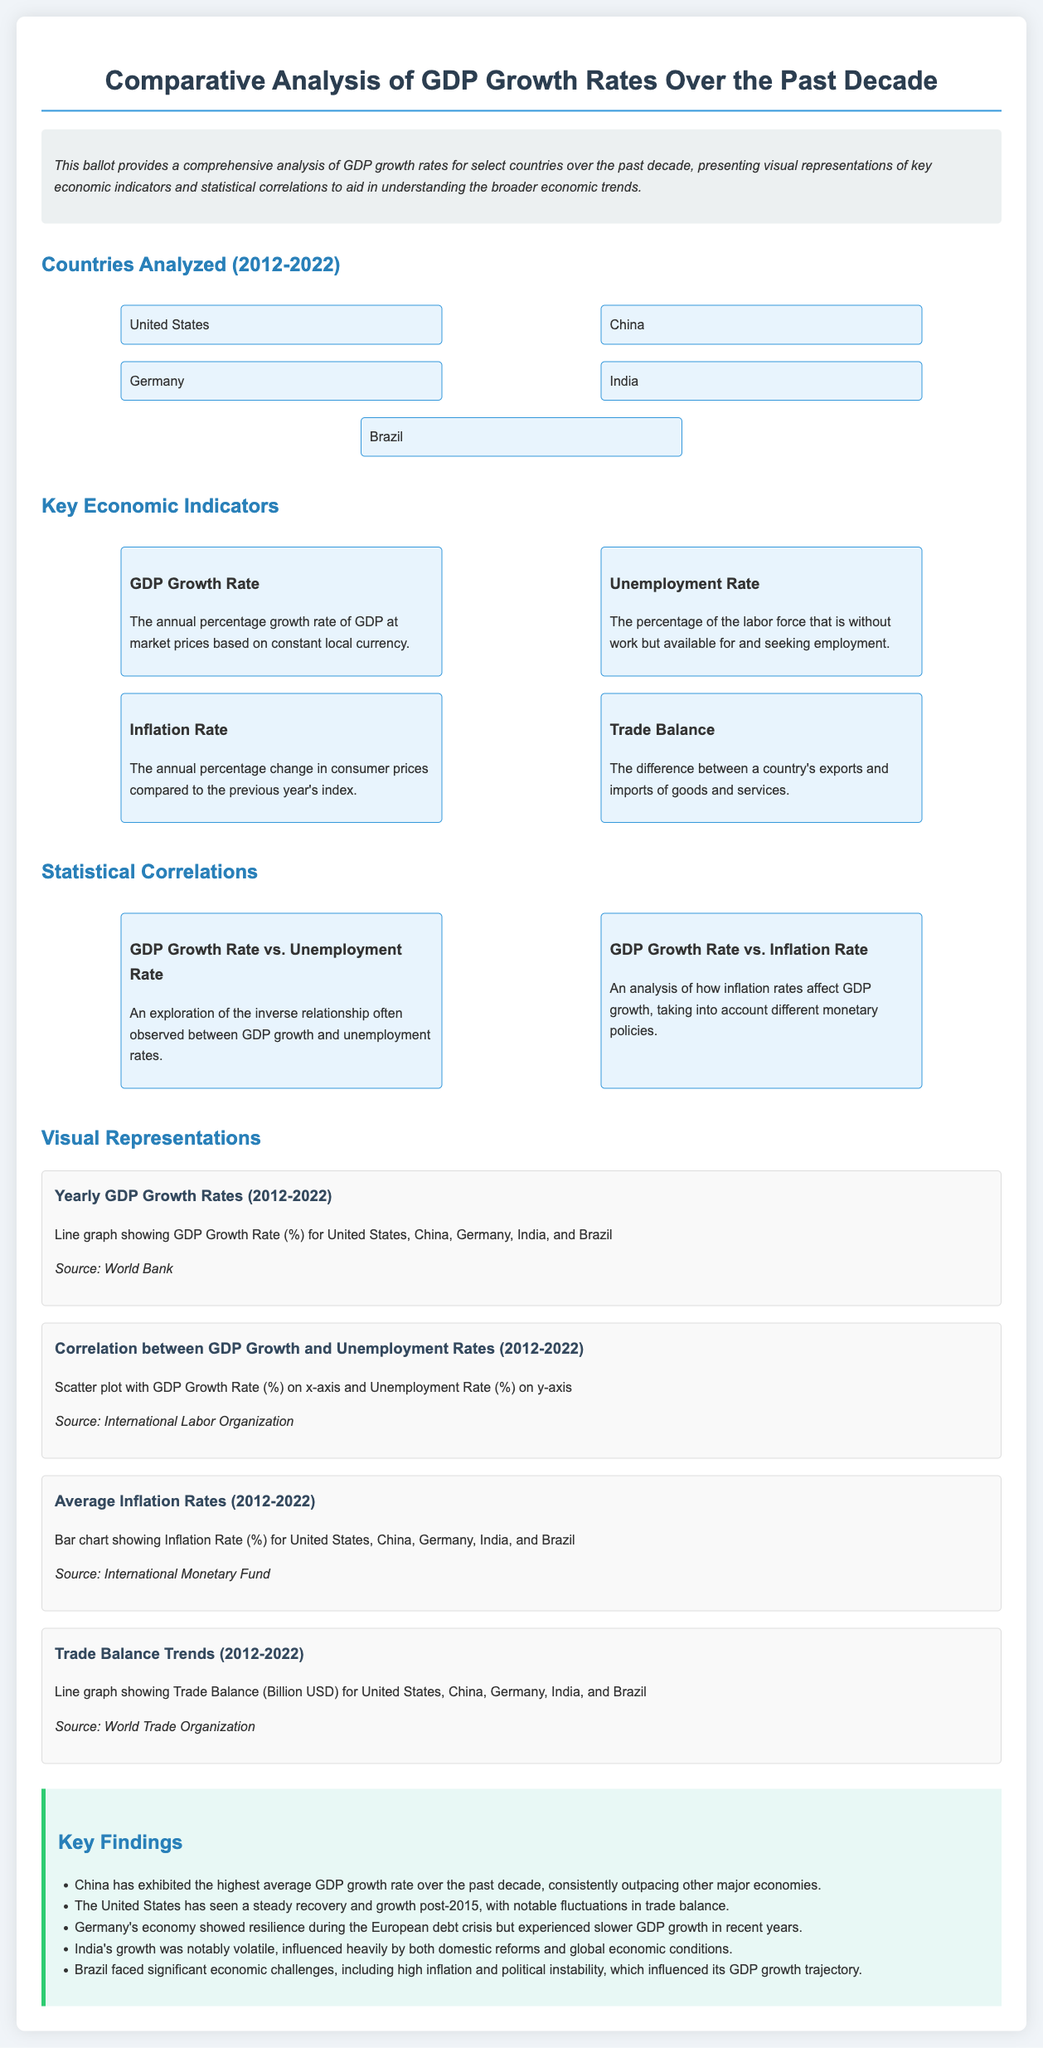What countries are analyzed? The document lists the countries analyzed for GDP growth rates, including United States, China, Germany, India, and Brazil.
Answer: United States, China, Germany, India, Brazil What is the GDP growth rate? The GDP growth rate is defined in the document as the annual percentage growth rate of GDP at market prices based on constant local currency.
Answer: Annual percentage growth rate Which country had the highest GDP growth rate? Based on key findings, China exhibited the highest average GDP growth rate over the past decade.
Answer: China What few indicators are compared in this analysis? The document mentions multiple economic indicators including GDP growth rate, unemployment rate, inflation rate, and trade balance.
Answer: GDP growth rate, unemployment rate, inflation rate, trade balance How did Germany’s economy perform in recent years? The key findings note that Germany showed resilience during the European debt crisis but experienced slower GDP growth in recent years.
Answer: Slower GDP growth What type of correlation is explored between GDP growth and unemployment rates? The document discusses an inverse relationship often observed between GDP growth and unemployment rates.
Answer: Inverse relationship What does the scatter plot represent? According to the document, the scatter plot represents the correlation between GDP Growth Rate on the x-axis and Unemployment Rate on the y-axis.
Answer: Correlation between GDP Growth Rate and Unemployment Rate What trends does the line graph for Trade Balance depict? The line graph shows Trade Balance in Billion USD for the countries analyzed from 2012 to 2022.
Answer: Trade Balance trends What is the source for the yearly GDP growth rates visual representation? The document cites the World Bank as the source for the yearly GDP growth rates visual representation.
Answer: World Bank 